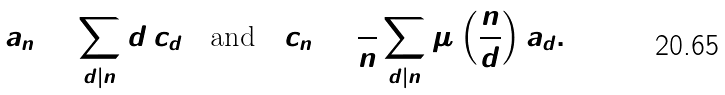Convert formula to latex. <formula><loc_0><loc_0><loc_500><loc_500>a _ { n } = \sum _ { d | n } d \, c _ { d } \quad \text {and} \quad c _ { n } = \frac { 1 } { n } \sum _ { d | n } \mu \left ( \frac { n } { d } \right ) a _ { d } .</formula> 